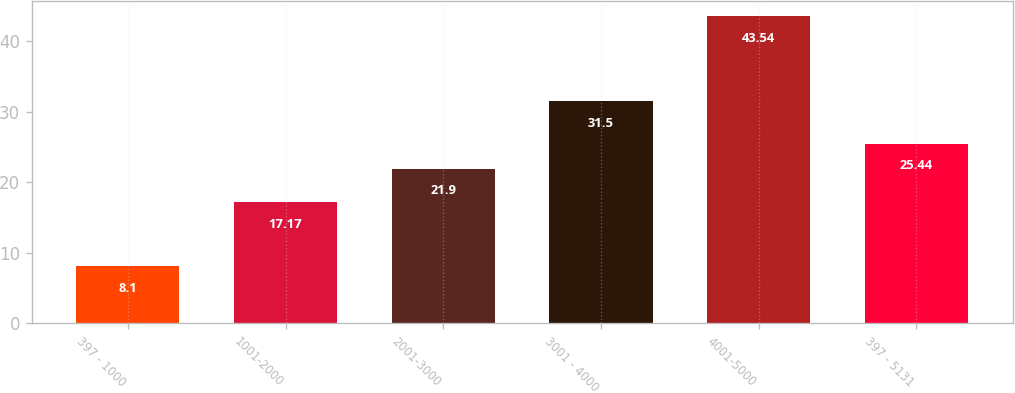Convert chart to OTSL. <chart><loc_0><loc_0><loc_500><loc_500><bar_chart><fcel>397 - 1000<fcel>1001-2000<fcel>2001-3000<fcel>3001 - 4000<fcel>4001-5000<fcel>397 - 5131<nl><fcel>8.1<fcel>17.17<fcel>21.9<fcel>31.5<fcel>43.54<fcel>25.44<nl></chart> 